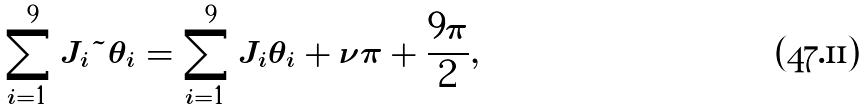<formula> <loc_0><loc_0><loc_500><loc_500>\sum _ { i = 1 } ^ { 9 } J _ { i } { \tilde { \theta } } _ { i } = \sum _ { i = 1 } ^ { 9 } J _ { i } \theta _ { i } + \nu \pi + \frac { 9 \pi } { 2 } ,</formula> 